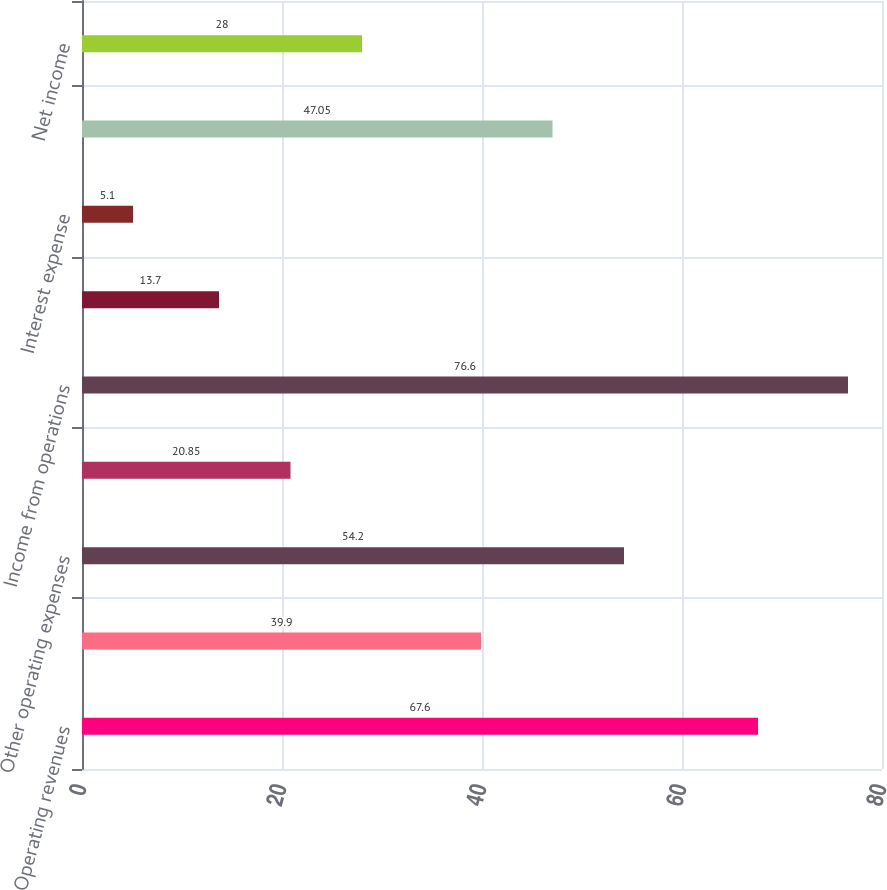Convert chart to OTSL. <chart><loc_0><loc_0><loc_500><loc_500><bar_chart><fcel>Operating revenues<fcel>Fuel and purchased power<fcel>Other operating expenses<fcel>Depreciation and amortization<fcel>Income from operations<fcel>Other income (expense) net<fcel>Interest expense<fcel>Income tax expense<fcel>Net income<nl><fcel>67.6<fcel>39.9<fcel>54.2<fcel>20.85<fcel>76.6<fcel>13.7<fcel>5.1<fcel>47.05<fcel>28<nl></chart> 